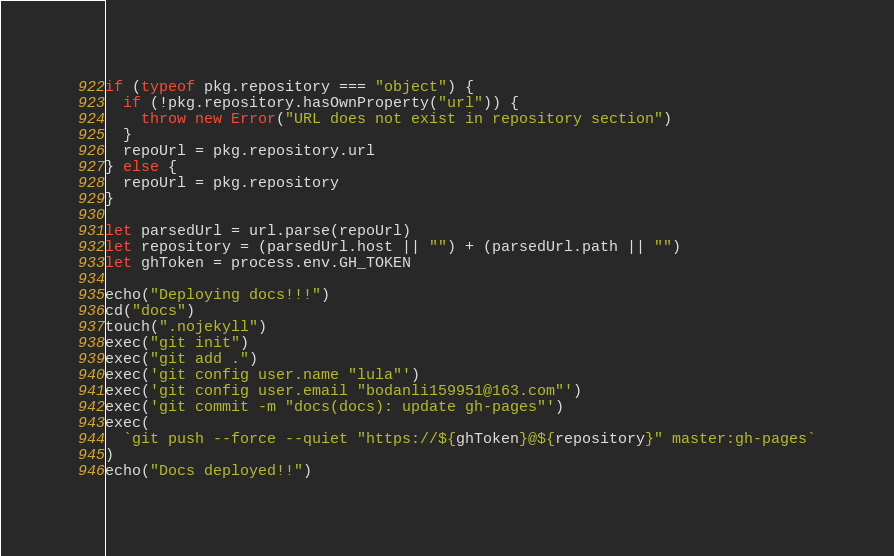Convert code to text. <code><loc_0><loc_0><loc_500><loc_500><_TypeScript_>if (typeof pkg.repository === "object") {
  if (!pkg.repository.hasOwnProperty("url")) {
    throw new Error("URL does not exist in repository section")
  }
  repoUrl = pkg.repository.url
} else {
  repoUrl = pkg.repository
}

let parsedUrl = url.parse(repoUrl)
let repository = (parsedUrl.host || "") + (parsedUrl.path || "")
let ghToken = process.env.GH_TOKEN

echo("Deploying docs!!!")
cd("docs")
touch(".nojekyll")
exec("git init")
exec("git add .")
exec('git config user.name "lula"')
exec('git config user.email "bodanli159951@163.com"')
exec('git commit -m "docs(docs): update gh-pages"')
exec(
  `git push --force --quiet "https://${ghToken}@${repository}" master:gh-pages`
)
echo("Docs deployed!!")
</code> 